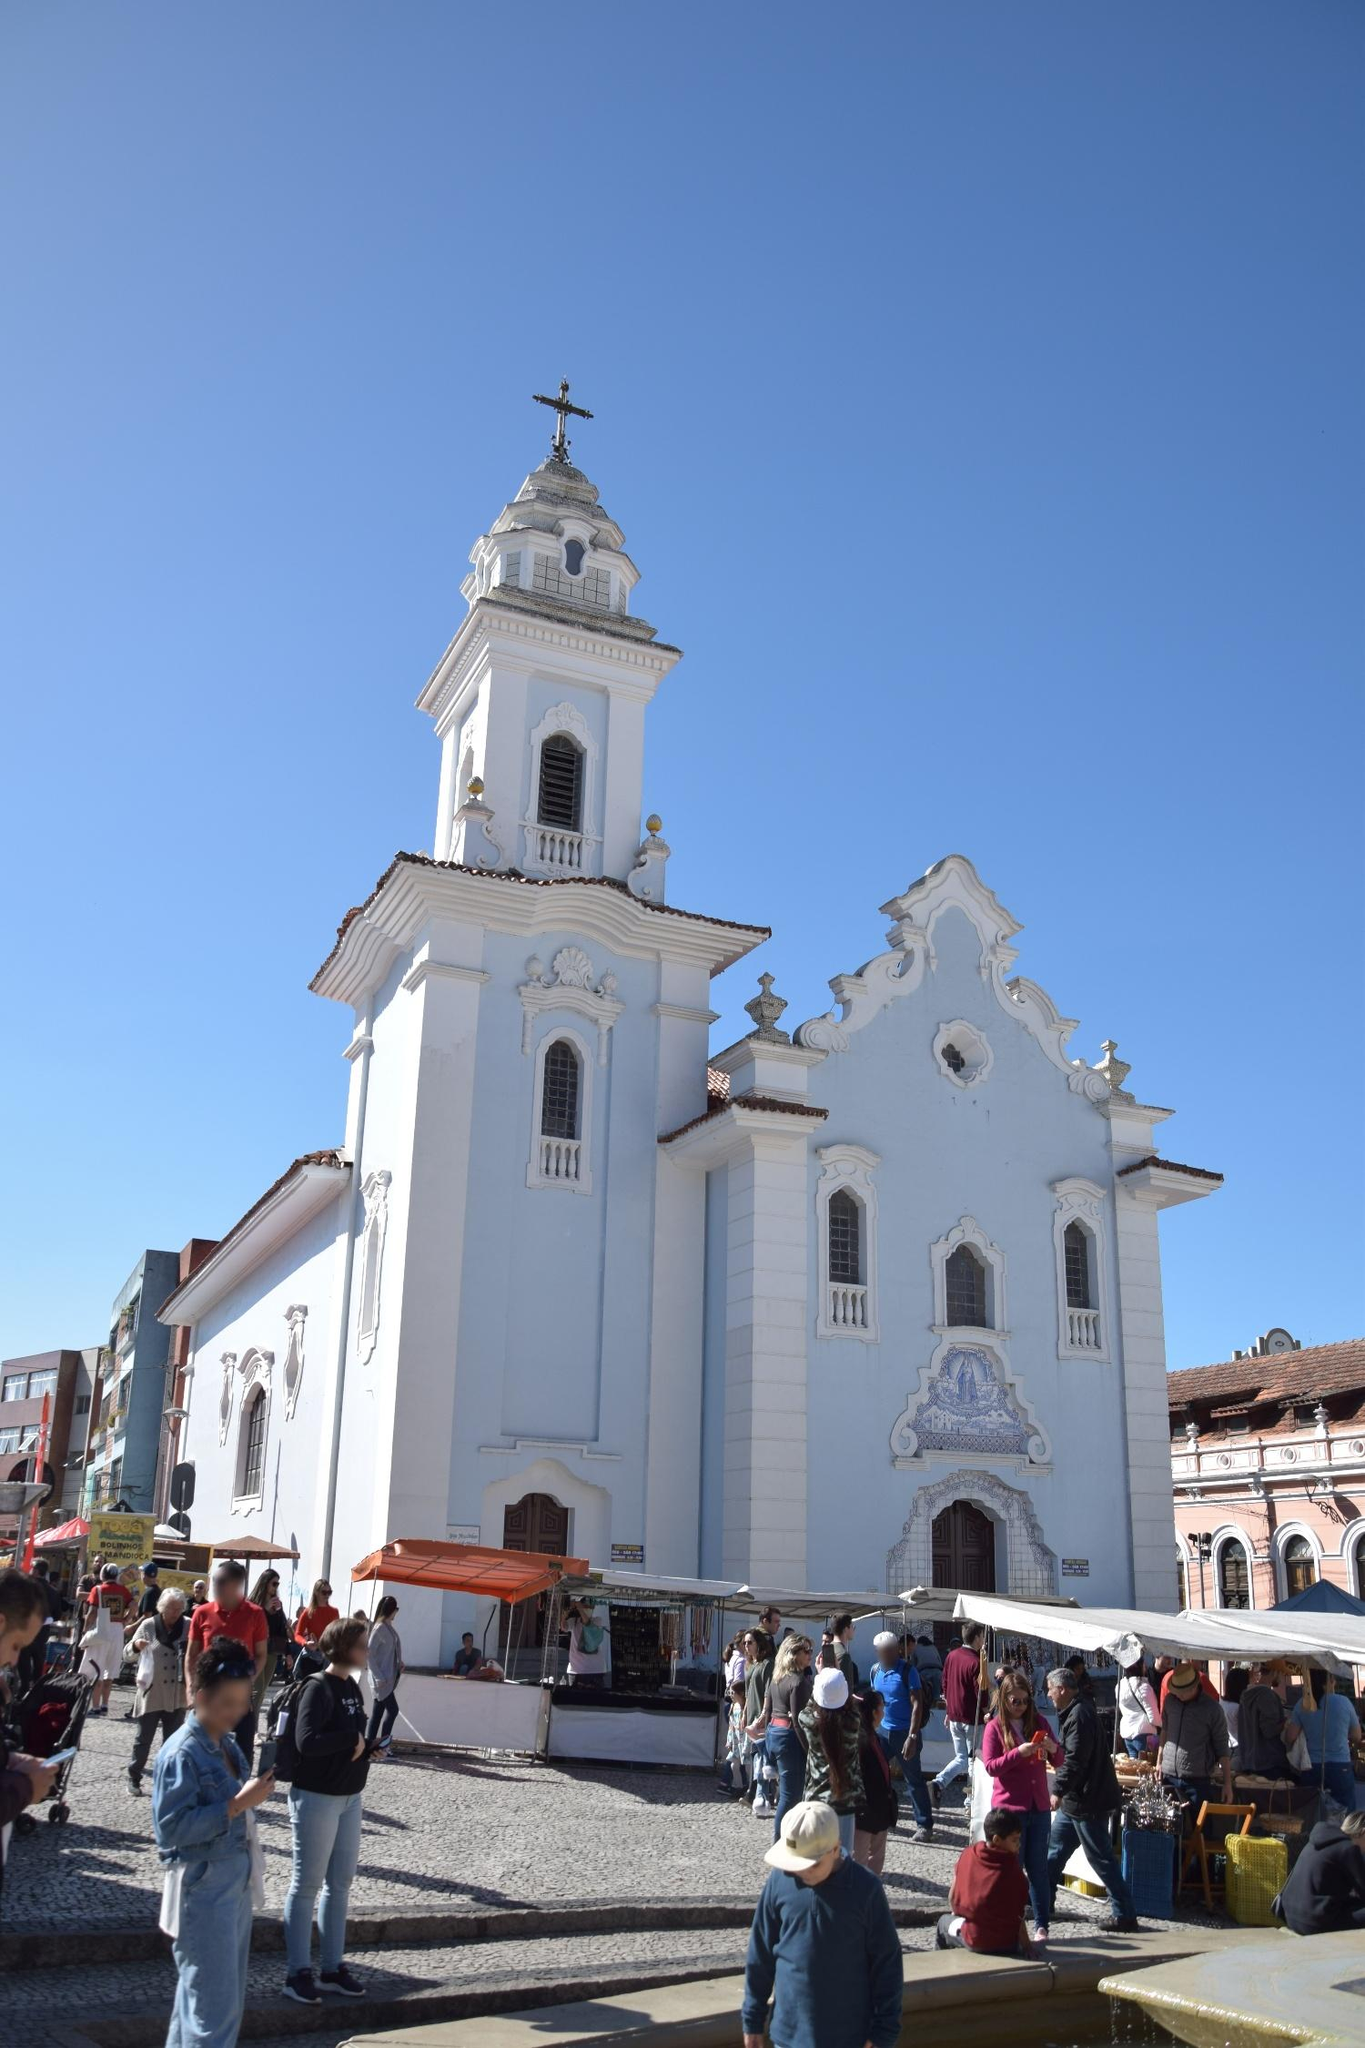Could you tell me about the architectural style of this church? The Igreja de Nossa Senhora do Rosário dos Pretos is a sublime example of Baroque architecture, a style that flourished in Europe during the 17th and 18th centuries. Baroque architecture is known for its grandiose, detailed designs and dramatic use of light and shadow. This church displays classic Baroque elements with its intricate facade adorned with ornamental arches and detailed stucco work. The bell tower and the cross on top of it further accentuate the verticality and grandeur typical of Baroque structures. The large arched entrance and the smaller arched window above it add depth and perspective, making the building appear even more imposing. The overall design not only reflects the ornate aesthetics but also serves to inspire a sense of awe and reverence in onlookers, perfectly marrying artistry with spirituality. In a futuristic twist, imagine if the church got transported to the year 3023! How would it adapt and fit into its new environment? In the year 3023, the Igreja de Nossa Senhora do Rosário dos Pretos would stand as a timeless relic amidst a landscape of advanced technology and ultramodern skyscrapers. Adapting to its futuristic environment, the church could be integrated with advanced preservation technologies to maintain its historic facade while incorporating sustainable energy sources like solar panels subtly hidden within its structure. Holographic guides might offer virtual tours, narrating the church's rich history to visitors. Digital stained-glass windows could display changing scenes, blending traditional art with modern innovation. Despite these technological enhancements, the core purpose of the church would remain unchanged, continuing to be a sanctuary of peace, spirituality, and cultural heritage in a high-tech era. It would symbolize the enduring significance of history and faith, standing proudly amidst the ever-evolving cityscape. What kind of events or festivals take place around this church? The area around the Igreja de Nossa Senhora do Rosário dos Pretos frequently hosts a variety of events and festivals that reflect the cultural and historical essence of Salvador. One of the most notable events is the 'Festa do Rosário', a vibrant celebration held annually to honor the church’s patron saint. This festival includes processions, traditional music, dance performances, and community feasts. Additionally, the church is a key site during Carnival, where it serves as a backdrop to lively street parades filled with colorful costumes, sharegpt4v/samba music, and dancing. Throughout the year, the square around the church also hosts cultural markets, art fairs, and religious ceremonies, making it a center of continual celebration and communal gathering. 